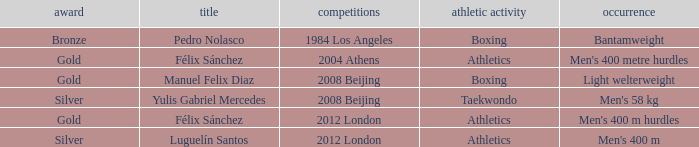Which Games had a Name of manuel felix diaz? 2008 Beijing. 